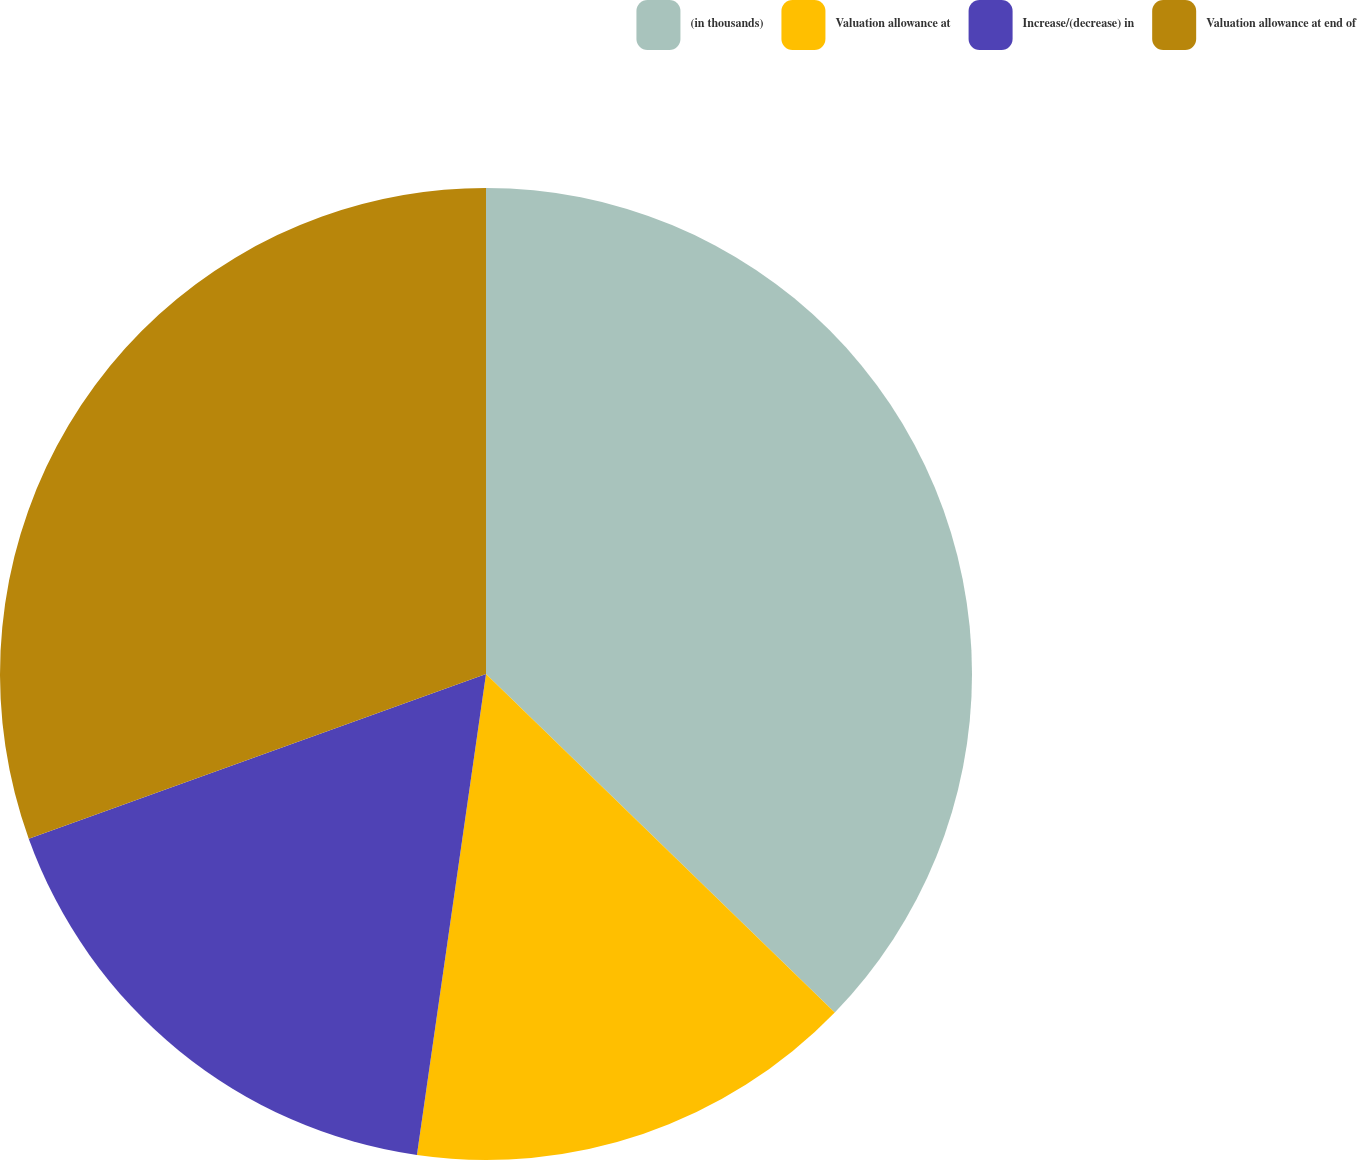Convert chart. <chart><loc_0><loc_0><loc_500><loc_500><pie_chart><fcel>(in thousands)<fcel>Valuation allowance at<fcel>Increase/(decrease) in<fcel>Valuation allowance at end of<nl><fcel>37.26%<fcel>15.01%<fcel>17.23%<fcel>30.5%<nl></chart> 